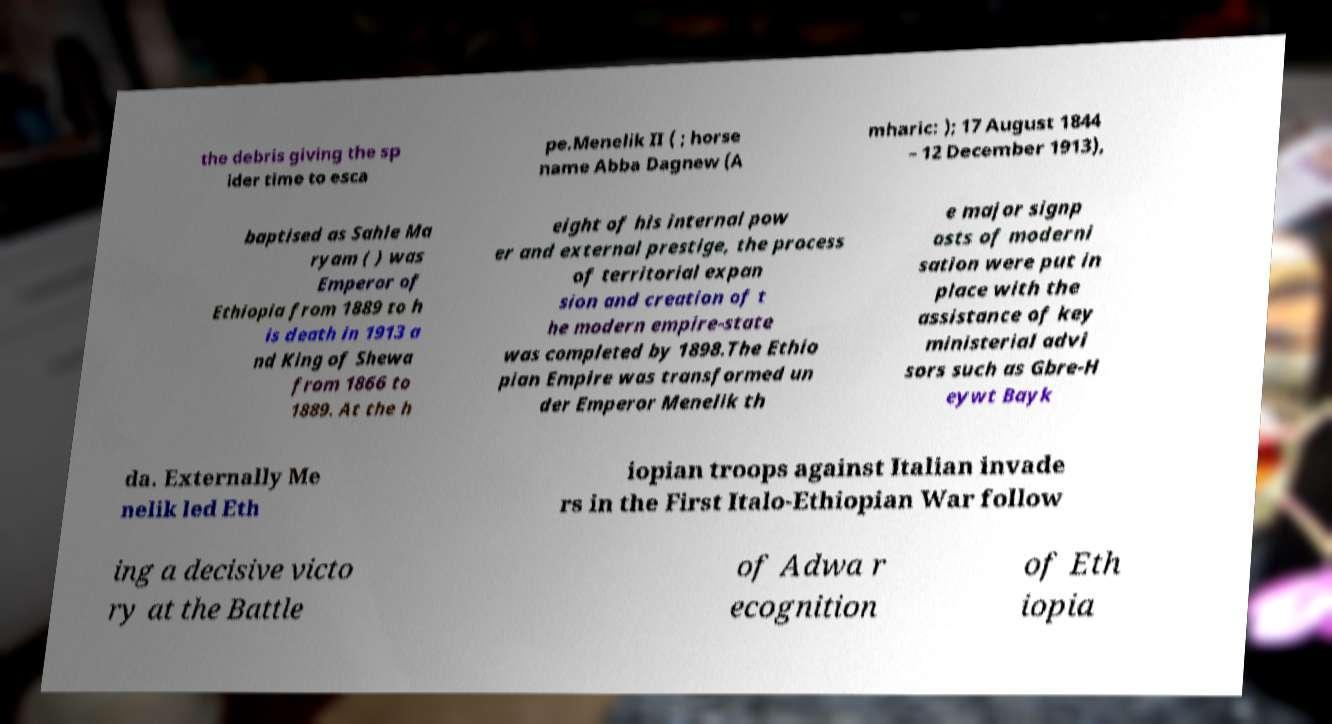Please identify and transcribe the text found in this image. the debris giving the sp ider time to esca pe.Menelik II ( ; horse name Abba Dagnew (A mharic: ); 17 August 1844 – 12 December 1913), baptised as Sahle Ma ryam ( ) was Emperor of Ethiopia from 1889 to h is death in 1913 a nd King of Shewa from 1866 to 1889. At the h eight of his internal pow er and external prestige, the process of territorial expan sion and creation of t he modern empire-state was completed by 1898.The Ethio pian Empire was transformed un der Emperor Menelik th e major signp osts of moderni sation were put in place with the assistance of key ministerial advi sors such as Gbre-H eywt Bayk da. Externally Me nelik led Eth iopian troops against Italian invade rs in the First Italo-Ethiopian War follow ing a decisive victo ry at the Battle of Adwa r ecognition of Eth iopia 